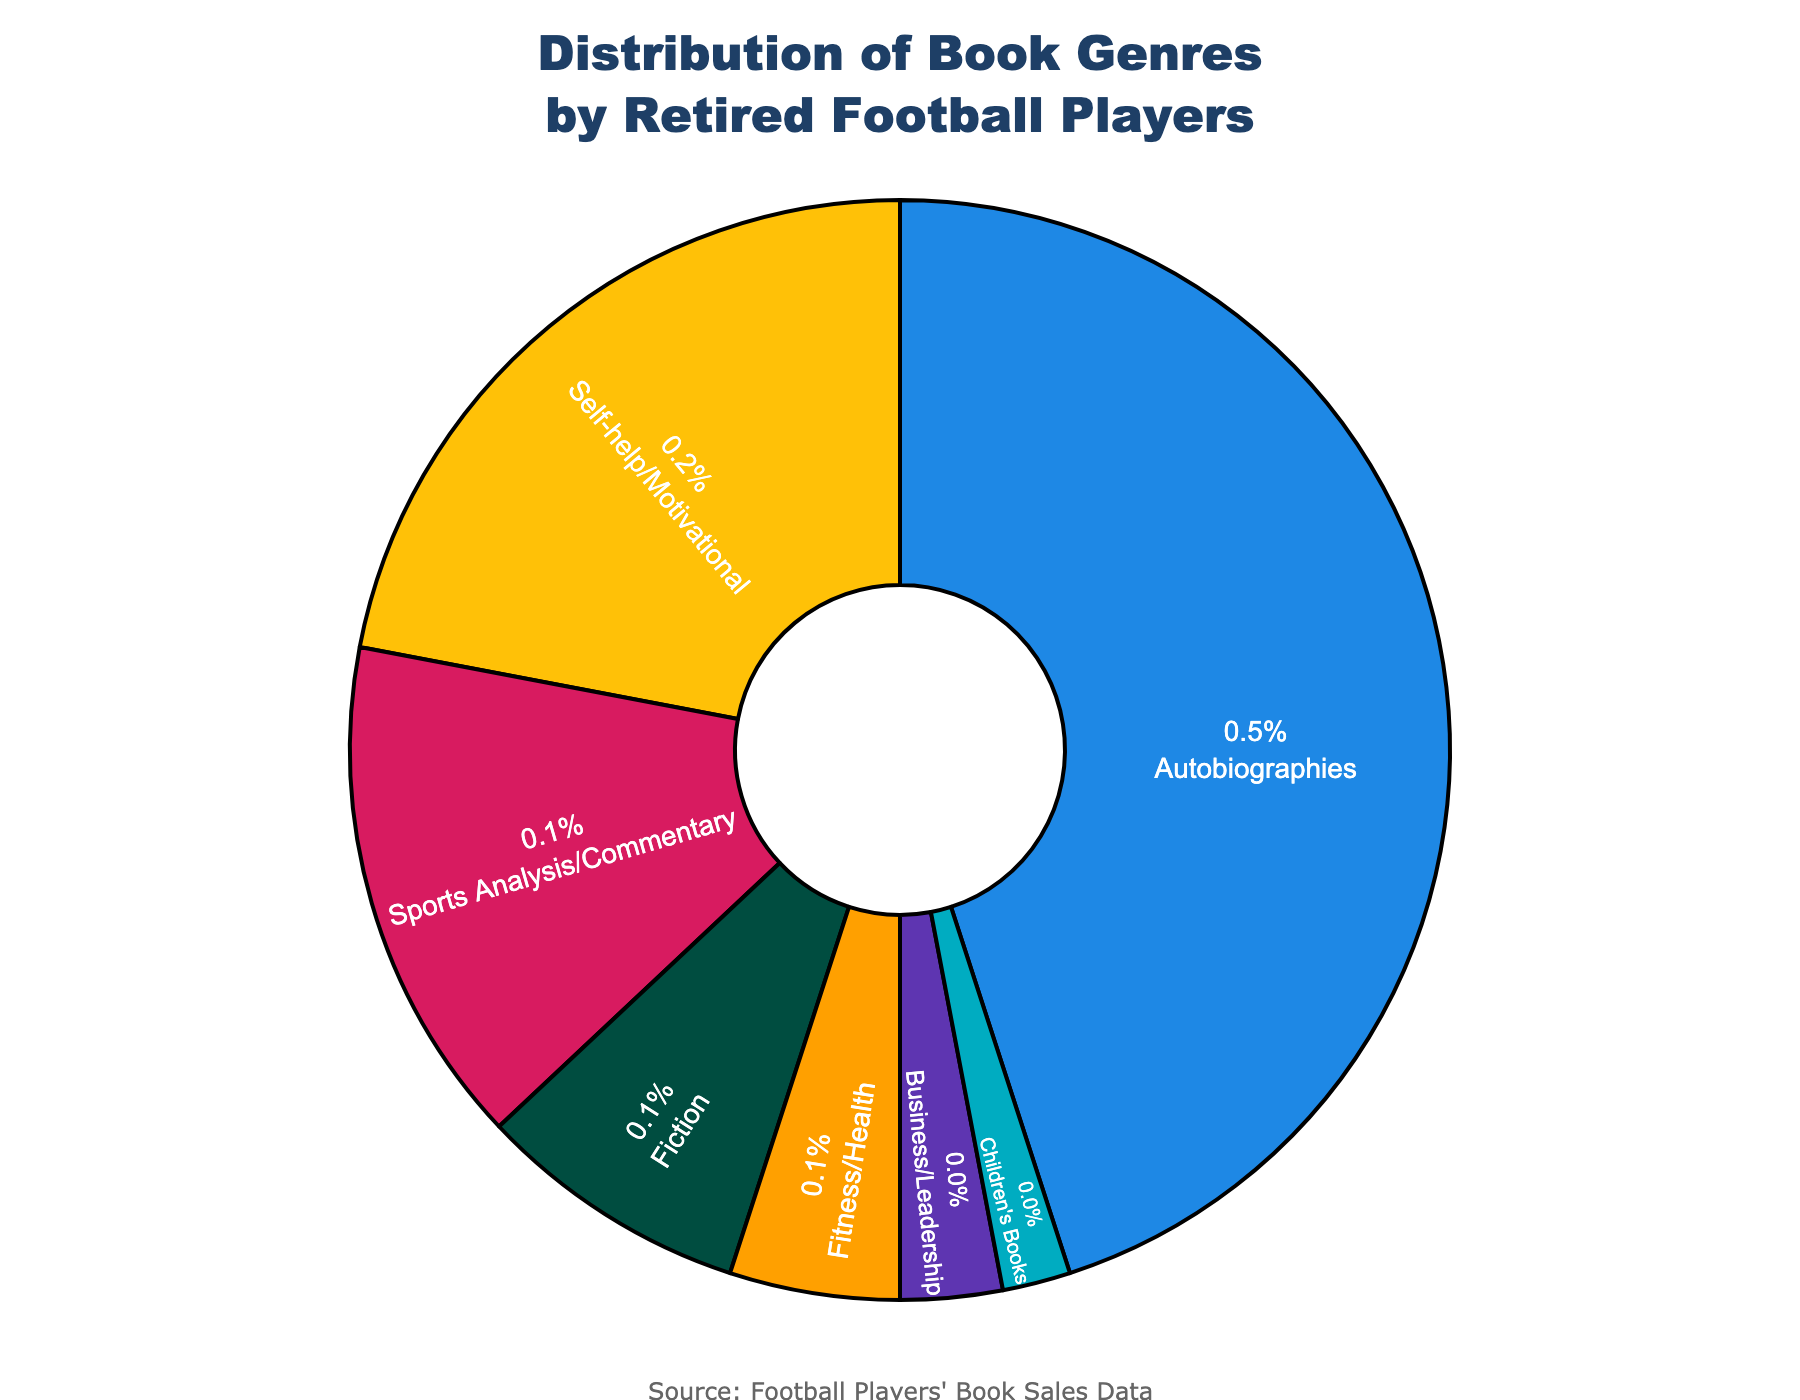What is the most popular book genre among retired football players? The figure shows the percentage distribution of different book genres. The genre with the highest percentage indicates the most popular genre. From the visual, Autobiographies have the largest slice at 45%.
Answer: Autobiographies Which genre has a higher percentage, Fiction or Self-help/Motivational? By visually comparing the sizes of the slices for Fiction and Self-help/Motivational, it's evident that Self-help/Motivational has a larger percentage (22%) compared to Fiction (8%).
Answer: Self-help/Motivational What is the combined percentage of Fitness/Health and Business/Leadership genres? To find the combined percentage, add the percentages of Fitness/Health (5%) and Business/Leadership (3%). 5% + 3% = 8%.
Answer: 8% How much larger in percentage is Autobiographies compared to Children's Books? To determine this, subtract the percentage of Children's Books (2%) from Autobiographies (45%). 45% - 2% = 43%.
Answer: 43% Which genre occupies the smallest portion of the pie chart? The smallest portion of the pie chart is visually identifiable by the smallest slice. In this case, it is Children's Books at 2%.
Answer: Children's Books What percentage of the genres combined are Self-help/Motivational and Sports Analysis/Commentary? Adding the percentages of Self-help/Motivational (22%) and Sports Analysis/Commentary (15%) gives 22% + 15% = 37%.
Answer: 37% Which genre has a higher percentage, Business/Leadership or Fiction? Comparing the slices of Business/Leadership and Fiction, Fiction has a larger percentage (8%) compared to Business/Leadership (3%).
Answer: Fiction Which two genres combined make up nearly a quarter of the distribution? We need to find two genres whose combined total is close to 25%. Adding Self-help/Motivational (22%) and Fitness/Health (5%) gives a total of 27%, which is close to a quarter (25%).
Answer: Self-help/Motivational and Fitness/Health If you were to group Fiction, Fitness/Health, and Children's Books together, what would be their total percentage? Summing the percentages of Fiction (8%), Fitness/Health (5%), and Children's Books (2%) results in 8% + 5% + 2% = 15%.
Answer: 15% What is the difference in percentage between Autobiographies and Self-help/Motivational genres? Subtract the percentage of Self-help/Motivational (22%) from Autobiographies (45%). 45% - 22% = 23%.
Answer: 23% 